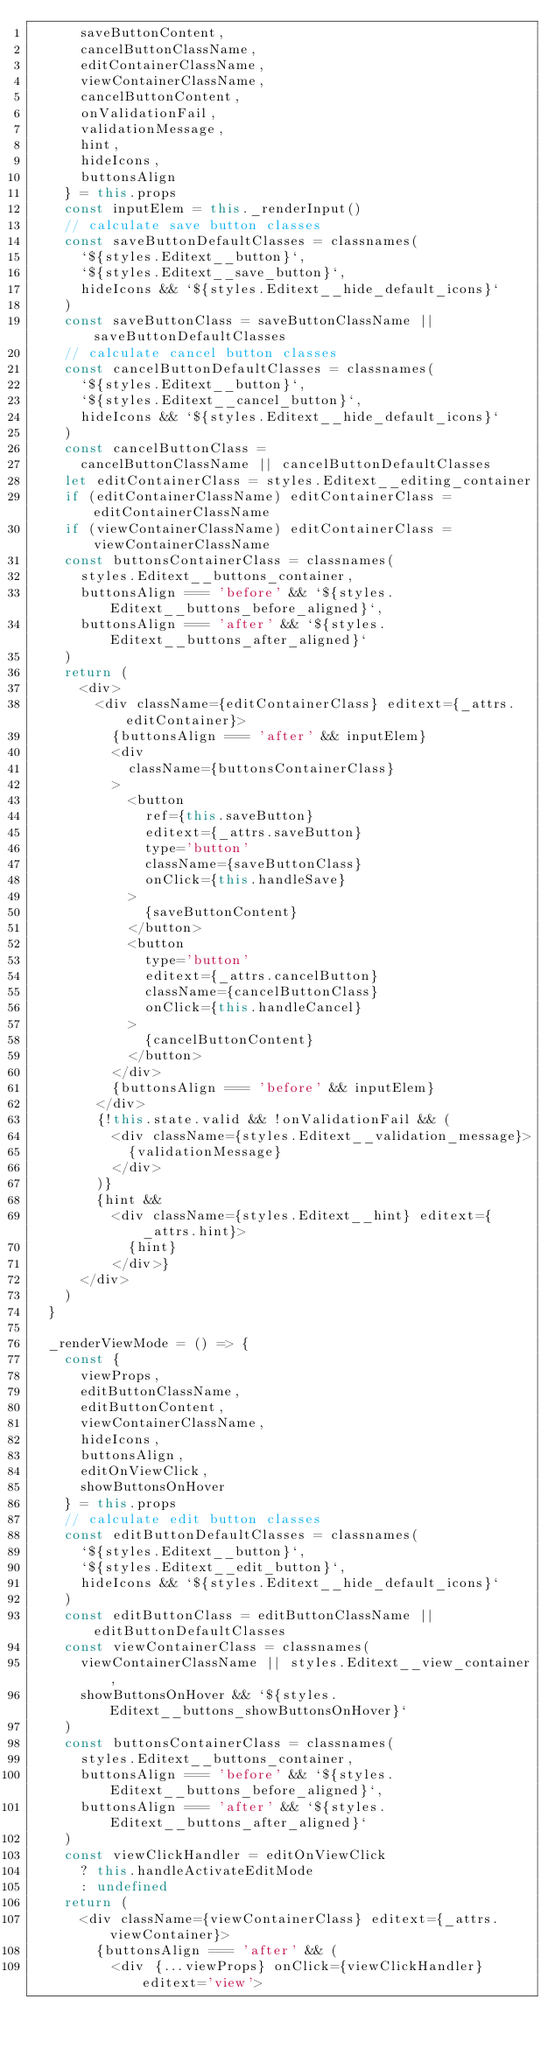<code> <loc_0><loc_0><loc_500><loc_500><_JavaScript_>      saveButtonContent,
      cancelButtonClassName,
      editContainerClassName,
      viewContainerClassName,
      cancelButtonContent,
      onValidationFail,
      validationMessage,
      hint,
      hideIcons,
      buttonsAlign
    } = this.props
    const inputElem = this._renderInput()
    // calculate save button classes
    const saveButtonDefaultClasses = classnames(
      `${styles.Editext__button}`,
      `${styles.Editext__save_button}`,
      hideIcons && `${styles.Editext__hide_default_icons}`
    )
    const saveButtonClass = saveButtonClassName || saveButtonDefaultClasses
    // calculate cancel button classes
    const cancelButtonDefaultClasses = classnames(
      `${styles.Editext__button}`,
      `${styles.Editext__cancel_button}`,
      hideIcons && `${styles.Editext__hide_default_icons}`
    )
    const cancelButtonClass =
      cancelButtonClassName || cancelButtonDefaultClasses
    let editContainerClass = styles.Editext__editing_container
    if (editContainerClassName) editContainerClass = editContainerClassName
    if (viewContainerClassName) editContainerClass = viewContainerClassName
    const buttonsContainerClass = classnames(
      styles.Editext__buttons_container,
      buttonsAlign === 'before' && `${styles.Editext__buttons_before_aligned}`,
      buttonsAlign === 'after' && `${styles.Editext__buttons_after_aligned}`
    )
    return (
      <div>
        <div className={editContainerClass} editext={_attrs.editContainer}>
          {buttonsAlign === 'after' && inputElem}
          <div
            className={buttonsContainerClass}
          >
            <button
              ref={this.saveButton}
              editext={_attrs.saveButton}
              type='button'
              className={saveButtonClass}
              onClick={this.handleSave}
            >
              {saveButtonContent}
            </button>
            <button
              type='button'
              editext={_attrs.cancelButton}
              className={cancelButtonClass}
              onClick={this.handleCancel}
            >
              {cancelButtonContent}
            </button>
          </div>
          {buttonsAlign === 'before' && inputElem}
        </div>
        {!this.state.valid && !onValidationFail && (
          <div className={styles.Editext__validation_message}>
            {validationMessage}
          </div>
        )}
        {hint &&
          <div className={styles.Editext__hint} editext={_attrs.hint}>
            {hint}
          </div>}
      </div>
    )
  }

  _renderViewMode = () => {
    const {
      viewProps,
      editButtonClassName,
      editButtonContent,
      viewContainerClassName,
      hideIcons,
      buttonsAlign,
      editOnViewClick,
      showButtonsOnHover
    } = this.props
    // calculate edit button classes
    const editButtonDefaultClasses = classnames(
      `${styles.Editext__button}`,
      `${styles.Editext__edit_button}`,
      hideIcons && `${styles.Editext__hide_default_icons}`
    )
    const editButtonClass = editButtonClassName || editButtonDefaultClasses
    const viewContainerClass = classnames(
      viewContainerClassName || styles.Editext__view_container,
      showButtonsOnHover && `${styles.Editext__buttons_showButtonsOnHover}`
    )
    const buttonsContainerClass = classnames(
      styles.Editext__buttons_container,
      buttonsAlign === 'before' && `${styles.Editext__buttons_before_aligned}`,
      buttonsAlign === 'after' && `${styles.Editext__buttons_after_aligned}`
    )
    const viewClickHandler = editOnViewClick
      ? this.handleActivateEditMode
      : undefined
    return (
      <div className={viewContainerClass} editext={_attrs.viewContainer}>
        {buttonsAlign === 'after' && (
          <div {...viewProps} onClick={viewClickHandler} editext='view'></code> 